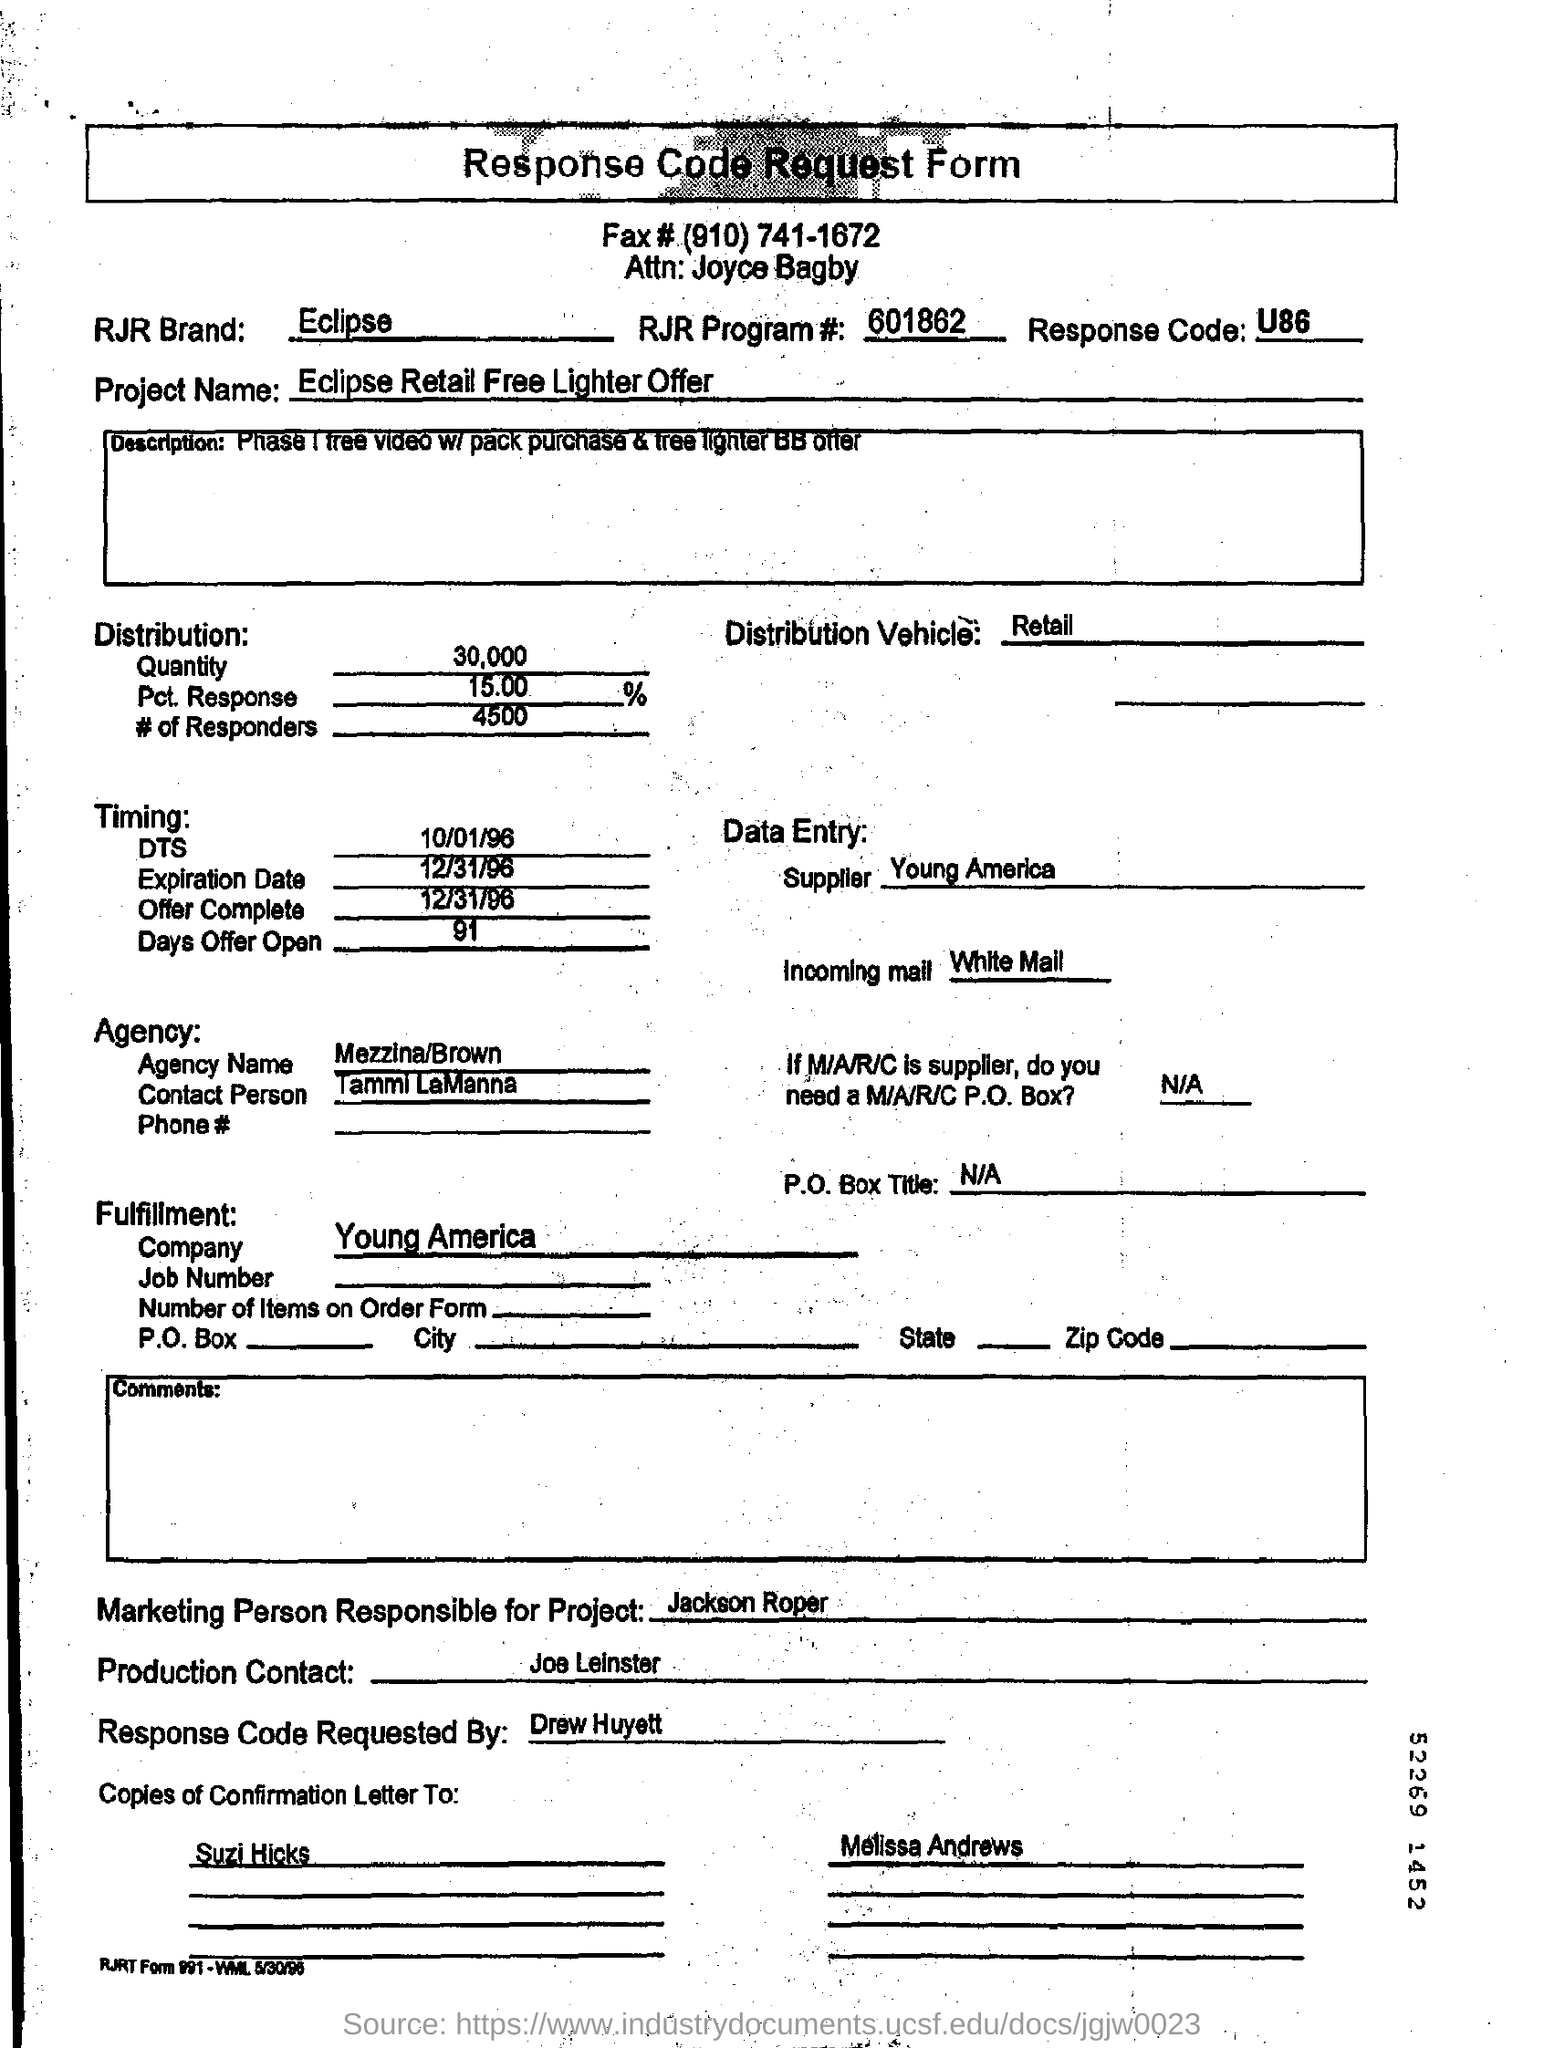What is the RJR Program #? The RJR Program Number, as stated on the Response Code Request Form, is 601862. 